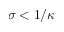Convert formula to latex. <formula><loc_0><loc_0><loc_500><loc_500>\sigma < 1 / \kappa</formula> 